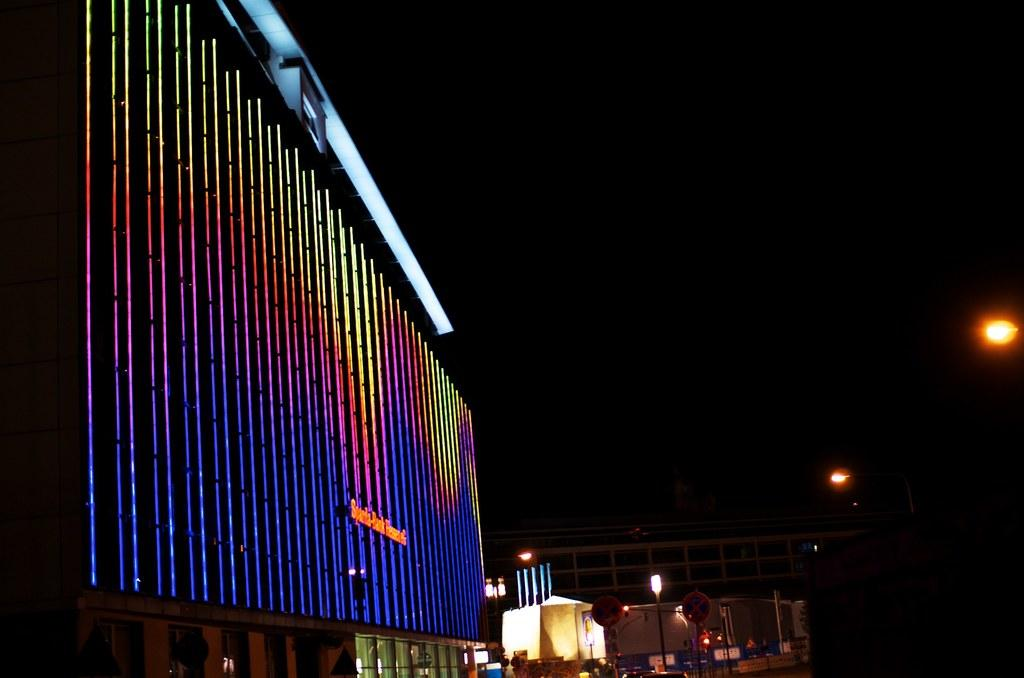What type of structures are illuminated in the image? There are buildings with lights in the image. What can be seen on the buildings? There is text visible on the buildings. What type of lighting is present in the image? Street lights are present in the image. What object can be seen in the image that might be used for displaying information? There is a board in the image. What type of objects are visible in the image that might be used for storage or transportation? Boxes are visible in the image. How would you describe the overall lighting condition in the image? The background of the image is dark. Is there a pancake being served at the club in the image? There is no club or pancake present in the image. How does the rain affect the visibility of the text on the buildings in the image? There is no rain present in the image, so it does not affect the visibility of the text on the buildings. 